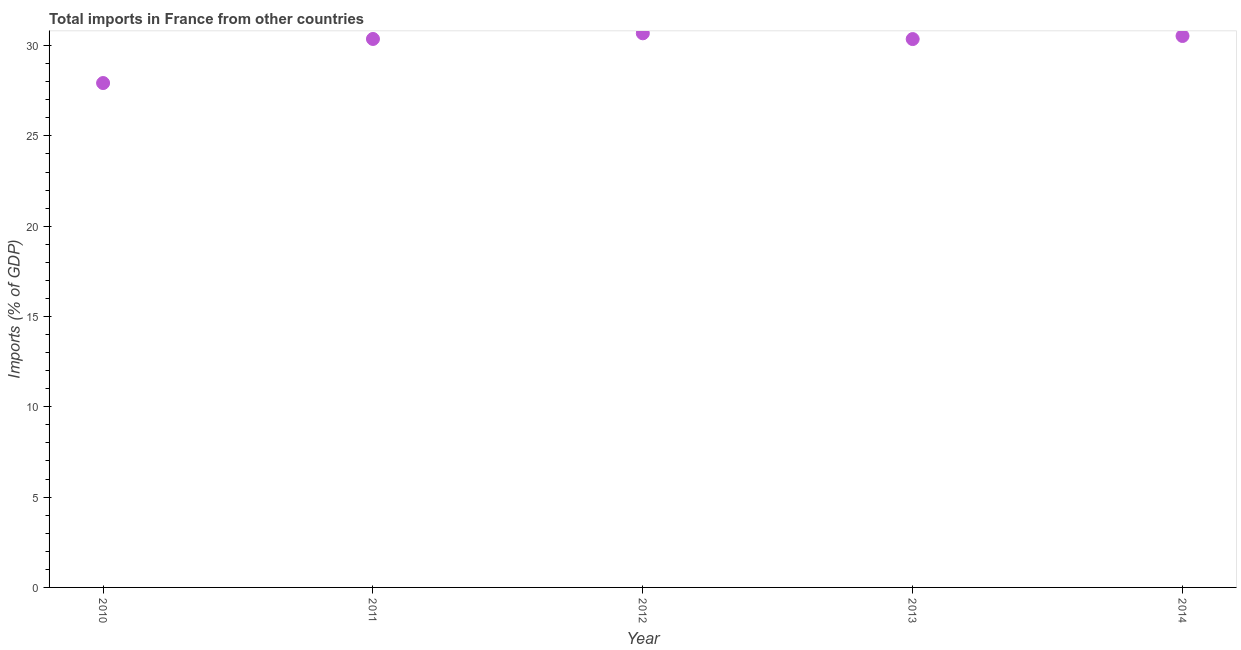What is the total imports in 2011?
Keep it short and to the point. 30.37. Across all years, what is the maximum total imports?
Offer a very short reply. 30.68. Across all years, what is the minimum total imports?
Your response must be concise. 27.93. What is the sum of the total imports?
Provide a short and direct response. 149.86. What is the difference between the total imports in 2013 and 2014?
Your answer should be compact. -0.17. What is the average total imports per year?
Your answer should be compact. 29.97. What is the median total imports?
Give a very brief answer. 30.37. What is the ratio of the total imports in 2010 to that in 2013?
Your answer should be very brief. 0.92. What is the difference between the highest and the second highest total imports?
Ensure brevity in your answer.  0.15. What is the difference between the highest and the lowest total imports?
Offer a terse response. 2.75. How many years are there in the graph?
Provide a succinct answer. 5. What is the difference between two consecutive major ticks on the Y-axis?
Make the answer very short. 5. Are the values on the major ticks of Y-axis written in scientific E-notation?
Your response must be concise. No. Does the graph contain any zero values?
Your answer should be very brief. No. Does the graph contain grids?
Provide a short and direct response. No. What is the title of the graph?
Your answer should be very brief. Total imports in France from other countries. What is the label or title of the Y-axis?
Your answer should be compact. Imports (% of GDP). What is the Imports (% of GDP) in 2010?
Your answer should be compact. 27.93. What is the Imports (% of GDP) in 2011?
Give a very brief answer. 30.37. What is the Imports (% of GDP) in 2012?
Ensure brevity in your answer.  30.68. What is the Imports (% of GDP) in 2013?
Offer a very short reply. 30.36. What is the Imports (% of GDP) in 2014?
Provide a succinct answer. 30.53. What is the difference between the Imports (% of GDP) in 2010 and 2011?
Keep it short and to the point. -2.44. What is the difference between the Imports (% of GDP) in 2010 and 2012?
Your response must be concise. -2.75. What is the difference between the Imports (% of GDP) in 2010 and 2013?
Your answer should be very brief. -2.43. What is the difference between the Imports (% of GDP) in 2010 and 2014?
Give a very brief answer. -2.61. What is the difference between the Imports (% of GDP) in 2011 and 2012?
Offer a terse response. -0.31. What is the difference between the Imports (% of GDP) in 2011 and 2013?
Keep it short and to the point. 0.01. What is the difference between the Imports (% of GDP) in 2011 and 2014?
Offer a terse response. -0.17. What is the difference between the Imports (% of GDP) in 2012 and 2013?
Your answer should be compact. 0.32. What is the difference between the Imports (% of GDP) in 2012 and 2014?
Give a very brief answer. 0.15. What is the difference between the Imports (% of GDP) in 2013 and 2014?
Offer a terse response. -0.17. What is the ratio of the Imports (% of GDP) in 2010 to that in 2012?
Give a very brief answer. 0.91. What is the ratio of the Imports (% of GDP) in 2010 to that in 2013?
Provide a short and direct response. 0.92. What is the ratio of the Imports (% of GDP) in 2010 to that in 2014?
Offer a very short reply. 0.92. What is the ratio of the Imports (% of GDP) in 2011 to that in 2013?
Ensure brevity in your answer.  1. What is the ratio of the Imports (% of GDP) in 2012 to that in 2013?
Provide a short and direct response. 1.01. What is the ratio of the Imports (% of GDP) in 2012 to that in 2014?
Offer a very short reply. 1. What is the ratio of the Imports (% of GDP) in 2013 to that in 2014?
Make the answer very short. 0.99. 